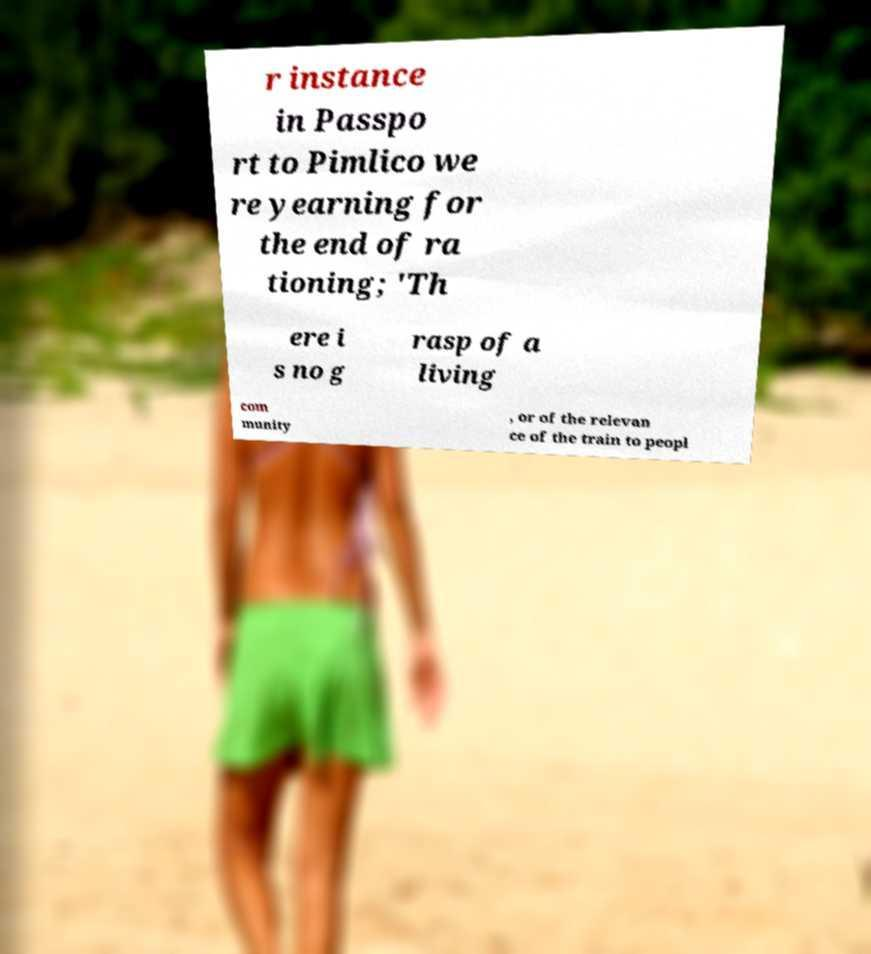Please identify and transcribe the text found in this image. r instance in Passpo rt to Pimlico we re yearning for the end of ra tioning; 'Th ere i s no g rasp of a living com munity , or of the relevan ce of the train to peopl 